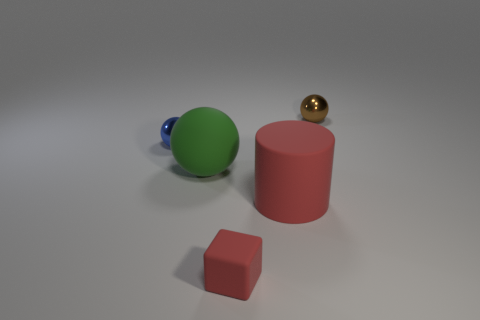What size is the other rubber thing that is the same color as the tiny matte thing?
Your answer should be very brief. Large. How many big rubber objects are the same color as the small rubber block?
Offer a terse response. 1. What is the size of the metallic object that is right of the tiny blue metallic object?
Provide a short and direct response. Small. Are there fewer big matte balls than small cyan metal balls?
Make the answer very short. No. Does the tiny thing behind the small blue thing have the same material as the red thing behind the matte block?
Your answer should be compact. No. There is a tiny thing that is in front of the small blue metal sphere that is behind the red rubber object in front of the cylinder; what shape is it?
Make the answer very short. Cube. How many big cylinders are made of the same material as the blue ball?
Your answer should be very brief. 0. What number of matte things are to the left of the ball left of the green ball?
Provide a succinct answer. 0. There is a tiny ball that is behind the blue thing; is it the same color as the small thing in front of the blue metallic ball?
Make the answer very short. No. The small thing that is behind the small matte object and on the left side of the big rubber cylinder has what shape?
Ensure brevity in your answer.  Sphere. 